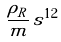<formula> <loc_0><loc_0><loc_500><loc_500>\frac { \rho _ { R } } m \, s ^ { 1 2 }</formula> 